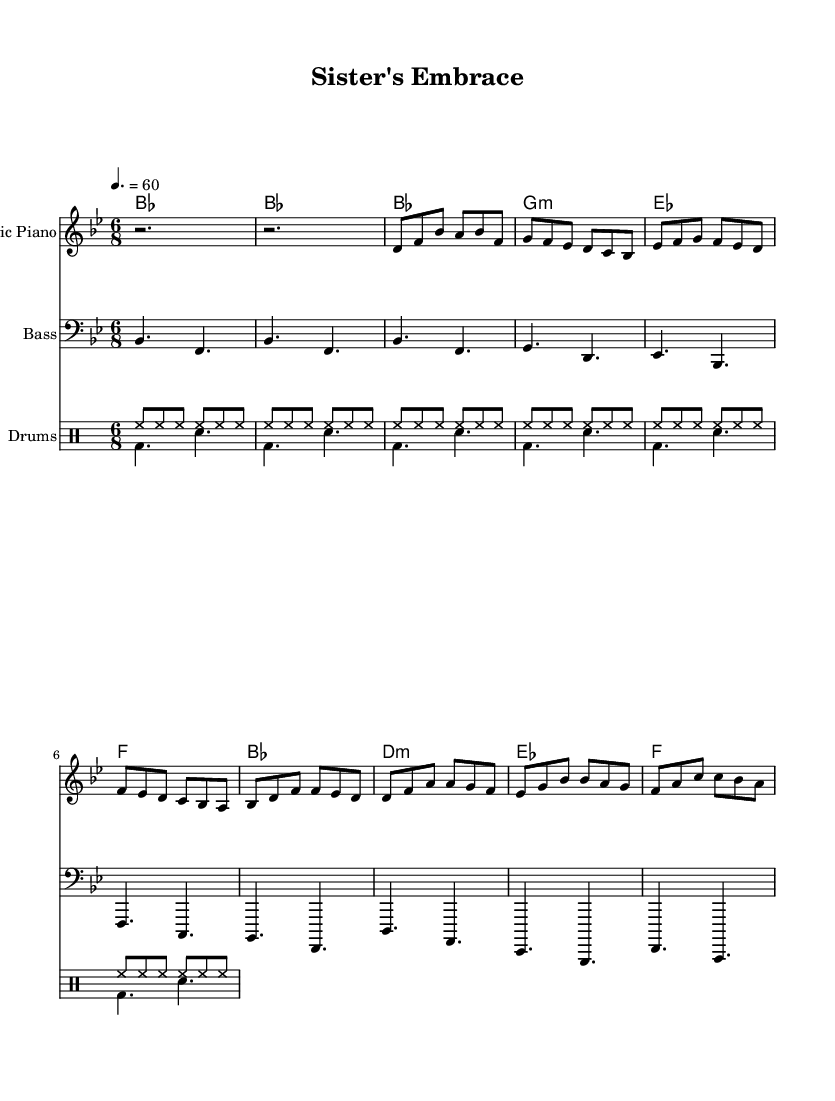What is the key signature of this music? The key signature is B flat major, which contains two flats: B flat and E flat. This can be determined by looking at the key signature indicated at the beginning of the music.
Answer: B flat major What is the time signature of this piece? The time signature is 6/8, which can be found at the beginning of the music before the notes start. This indicates there are six eighth notes per measure.
Answer: 6/8 What is the tempo marking for this composition? The tempo marking is quarter note equals 60, which is written at the start of the sheet music. This means there are 60 quarter note beats per minute.
Answer: 60 How many measures are there in the verse section? The verse section consists of 4 measures, which can be counted by examining the notation of the verse labeled in the music.
Answer: 4 What type of rhythmic feel does the first verse convey? The first verse conveys a flowing, swing feel typical of funk music, achieved through the combination of eighth notes and the 6/8 time signature encouraging a buoyant rhythm.
Answer: Swing Which instruments are featured in this score? The instruments featured in this score are Electric Piano, Bass, and Drums, which are explicitly written at the beginning of each staff.
Answer: Electric Piano, Bass, and Drums What is the primary chord used in the chorus section? The primary chord used in the chorus section is B flat major, which can be confirmed by the chord symbols above the staff during the chorus.
Answer: B flat major 